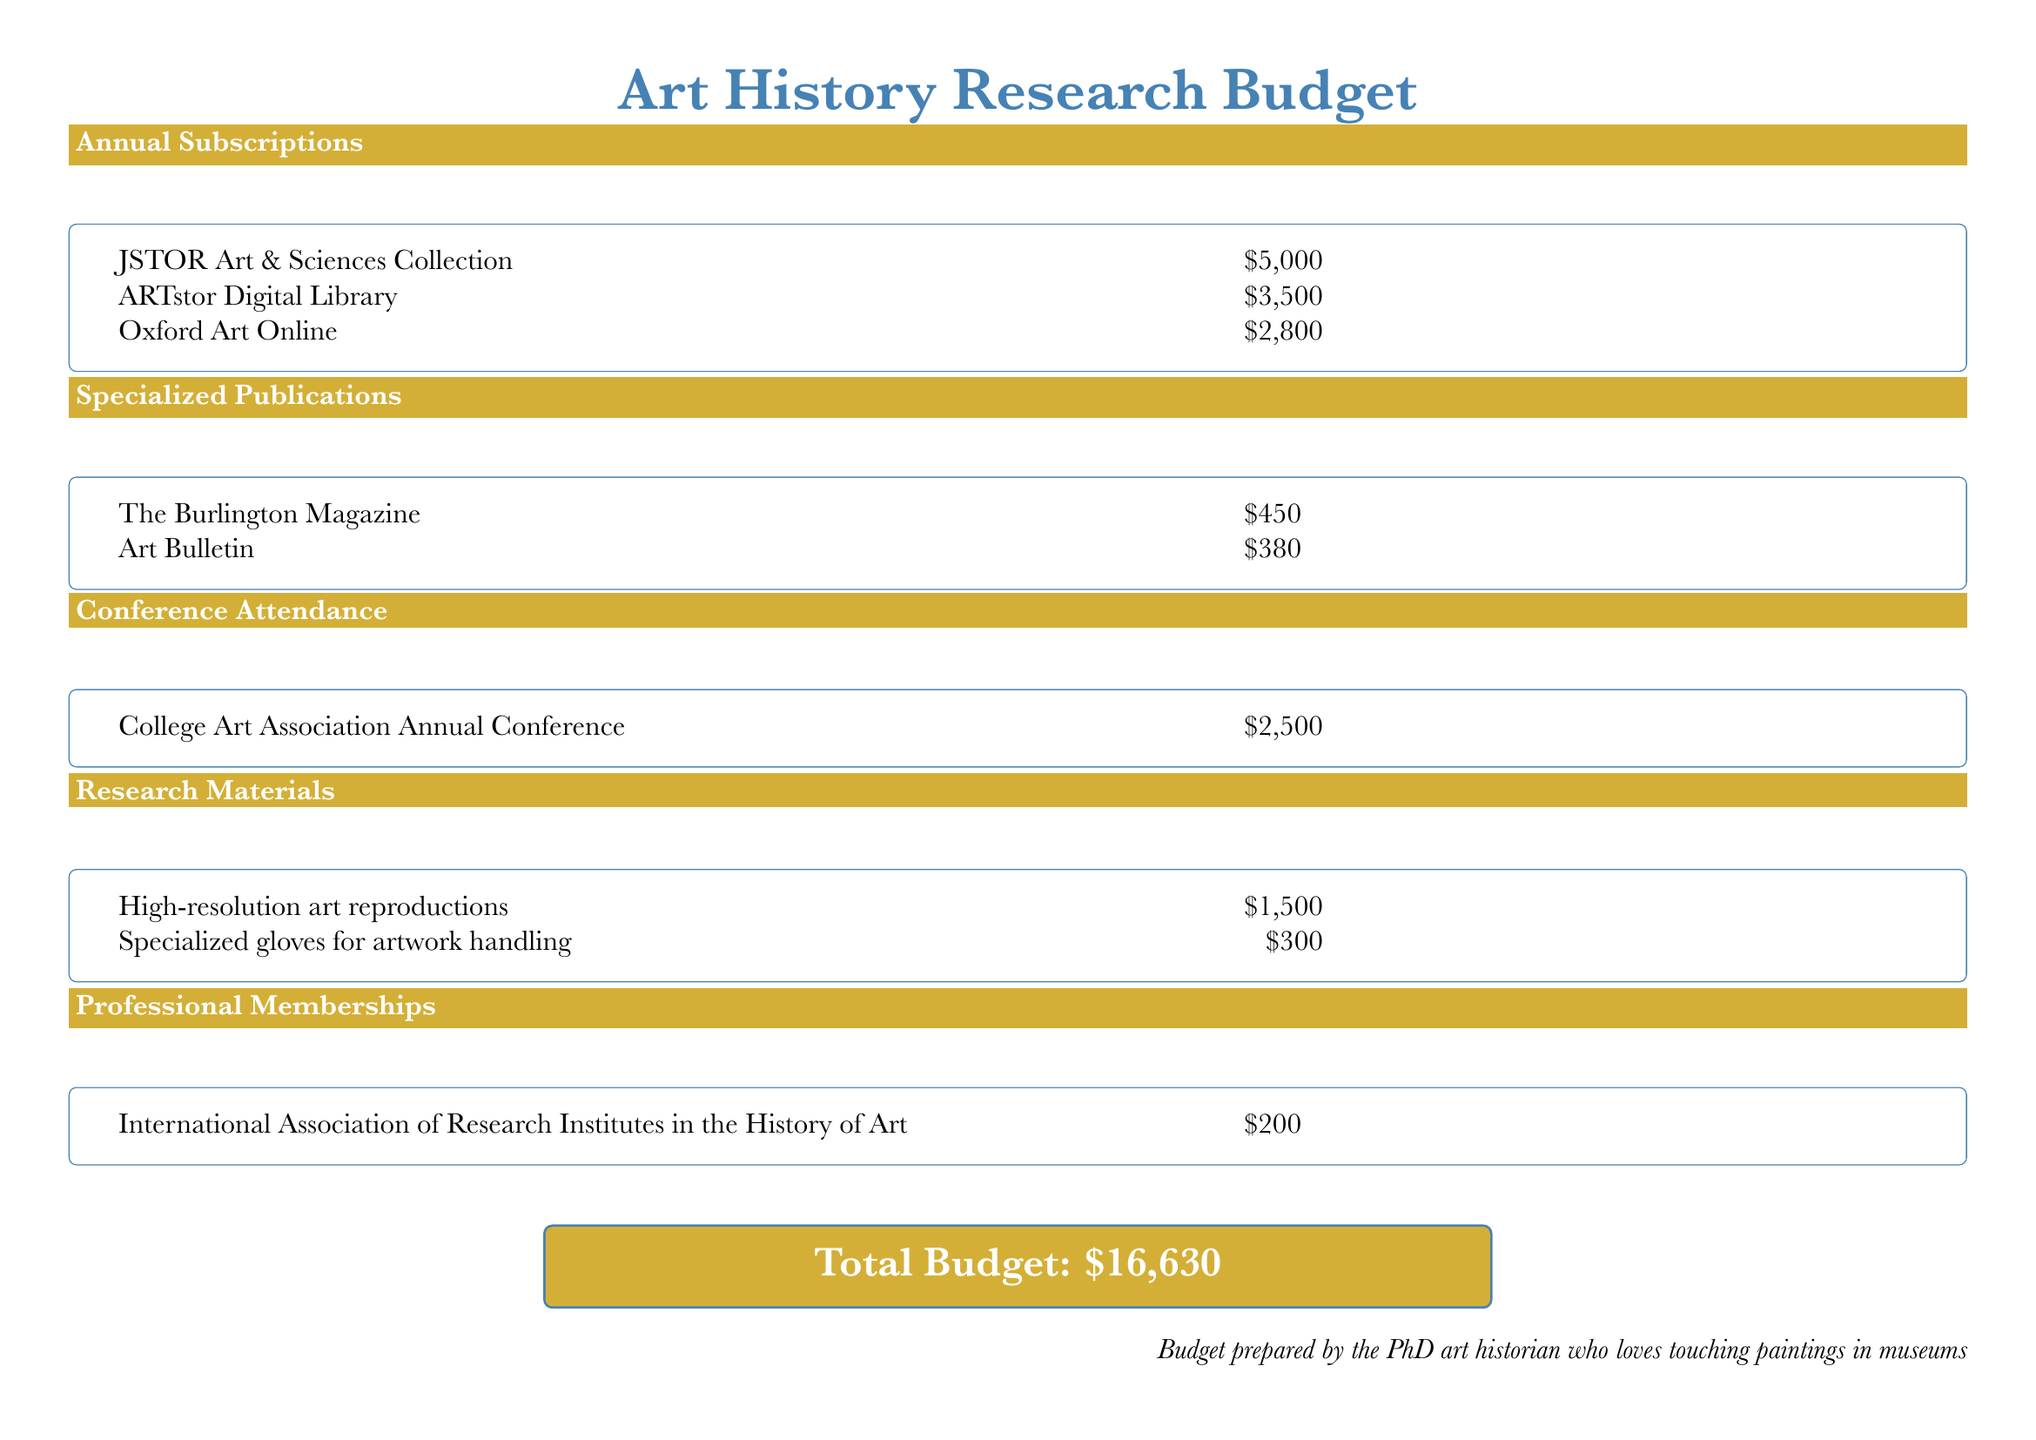What is the total budget? The total budget is listed at the bottom of the document and includes all allocations.
Answer: $16,630 How much is allocated for JSTOR Art & Sciences Collection? The specific figure for JSTOR Art & Sciences Collection is provided in the Annual Subscriptions section of the document.
Answer: $5,000 What is the cost of the Art Bulletin publication? The Art Bulletin publication cost is detailed in the Specialized Publications section of the document.
Answer: $380 Which professional membership is included in the budget? The Professional Memberships section lists an organization, which is the only one mentioned in this category.
Answer: International Association of Research Institutes in the History of Art How much is allocated for conference attendance? The Conference Attendance section provides a specific figure for the conference.
Answer: $2,500 What type of research material costs $300? The Research Materials section lists specific items, including the item that costs $300.
Answer: Specialized gloves for artwork handling What is the total amount allocated for Specialized Publications? This requires adding up the costs listed for each publication in the Specialized Publications section.
Answer: $830 Which database costs $2,800? The specific database name is listed in the Annual Subscriptions section of the document.
Answer: Oxford Art Online 